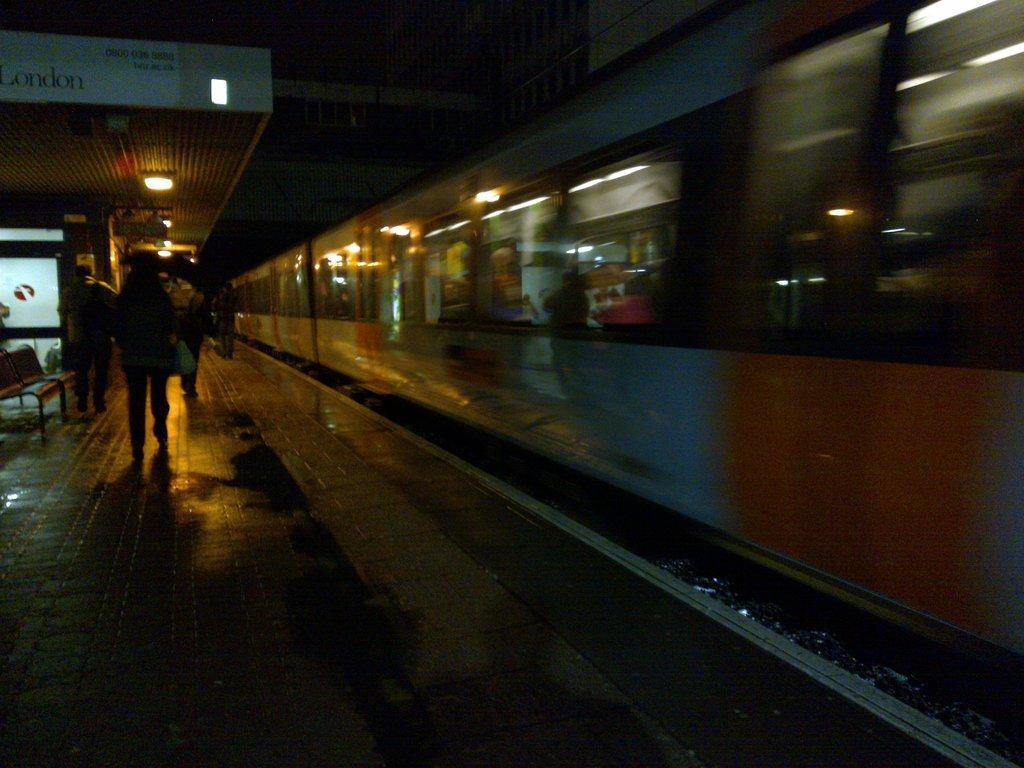Can you describe this image briefly? In the picture I can see a train on a railway track. I can also see people walking on the railway platform, lights on the ceiling and some other objects. This image is little bit dark. 